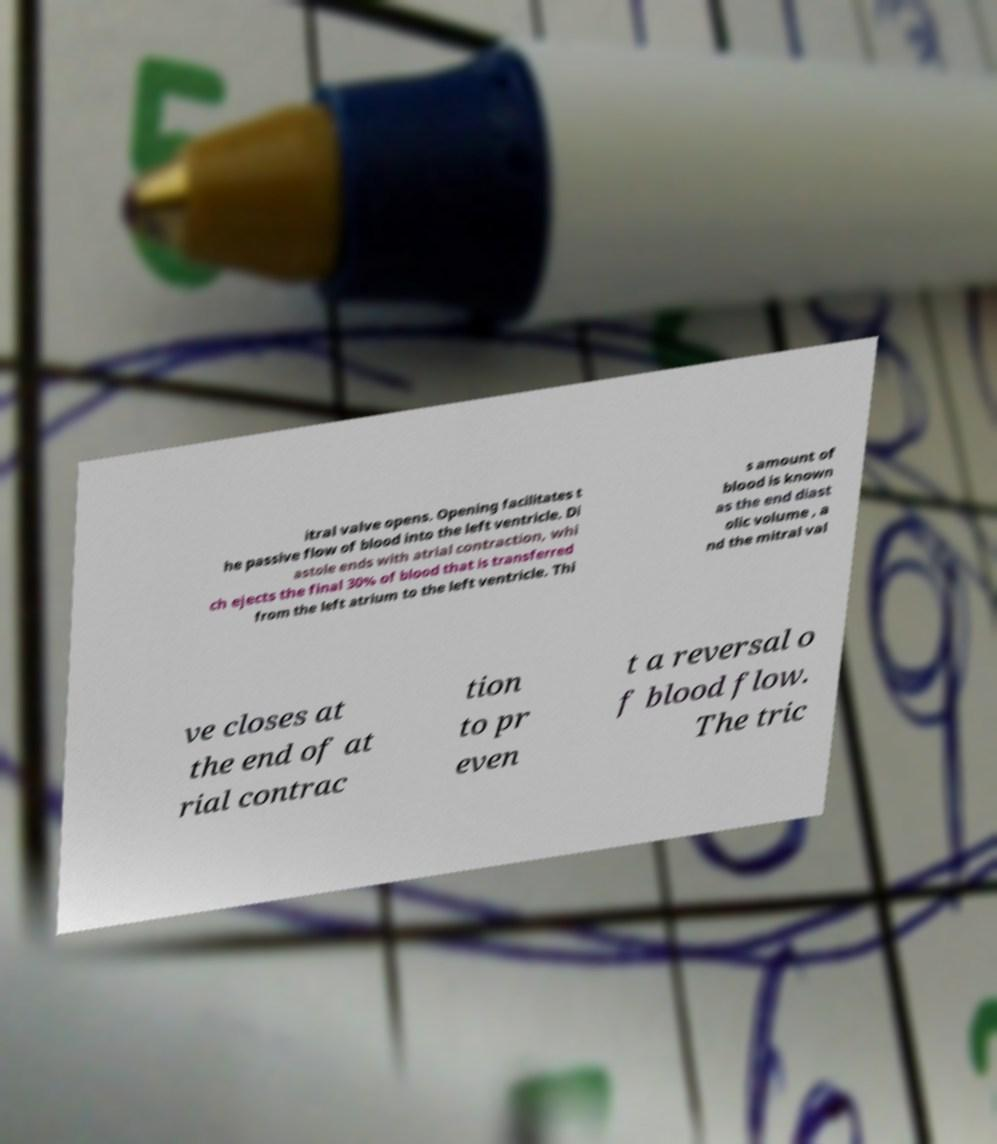Can you read and provide the text displayed in the image?This photo seems to have some interesting text. Can you extract and type it out for me? itral valve opens. Opening facilitates t he passive flow of blood into the left ventricle. Di astole ends with atrial contraction, whi ch ejects the final 30% of blood that is transferred from the left atrium to the left ventricle. Thi s amount of blood is known as the end diast olic volume , a nd the mitral val ve closes at the end of at rial contrac tion to pr even t a reversal o f blood flow. The tric 